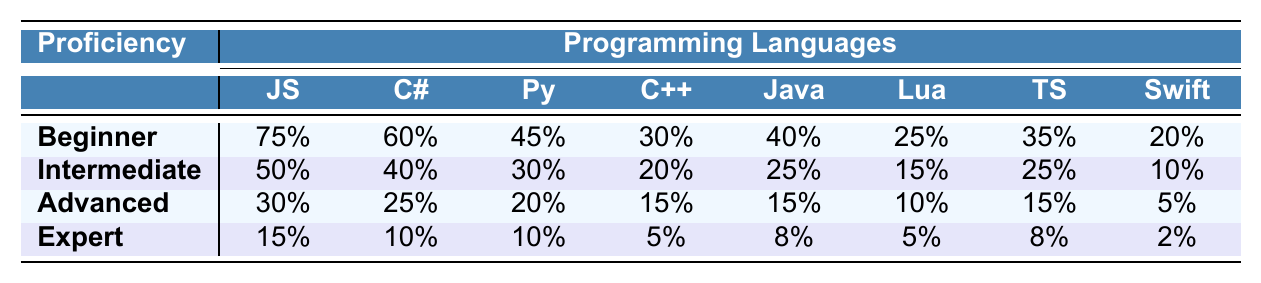What is the highest percentage of beginners in any programming language? The highest percentage of beginners is listed under the language "JavaScript," which has 75%.
Answer: 75% Which programming language has the least number of experts? The programming language with the least number of experts is "Swift," with only 2%.
Answer: 2% What is the average percentage of intermediate developers across all programming languages? To find the average for intermediate developers, sum the percentages (50 + 40 + 30 + 20 + 25 + 15 + 25 + 10) = 215. There are 8 languages, so the average is 215/8 = 26.875%.
Answer: 26.88% Is there any programming language where the percentage of beginners is higher than 70%? Yes, "JavaScript" has a percentage of 75% for beginners, which is higher than 70%.
Answer: Yes How many programming languages have a higher percentage of intermediate developers than advanced developers? The languages "JavaScript," "C#," and "Python" have higher percentages of intermediate developers (50%, 40%, and 30% respectively) compared to their advanced developers (30%, 25%, and 20% respectively). So, there are 3 languages.
Answer: 3 What is the difference in percentage between the highest and the lowest beginner proficiency levels? The highest is 75% (JavaScript) and the lowest is 20% (Swift). The difference is 75 - 20 = 55%.
Answer: 55% Which language has the highest percentage of advanced developers? "JavaScript" has the highest percentage of advanced developers, at 30%.
Answer: 30% What is the total percentage of intermediate and advanced developers in C++? For C++, the percentage of intermediate developers is 20% and advanced developers is 15%. The total is 20 + 15 = 35%.
Answer: 35% Is it true that the percentage of Lua developers is higher in the advanced category than in the expert category? Yes, the percentage of advanced Lua developers is 10%, while the expert category has only 5%.
Answer: Yes Which proficiency level is most common across the programming languages? The most common proficiency level overall is "Beginner," since it has the highest percentages across all languages.
Answer: Beginner What programming languages have an intermediate developer percentage of 25% or more? The programming languages with 25% or more intermediate developers are "JavaScript" (50%), "C#" (40%), and "Python" (30%).
Answer: JavaScript, C#, Python 